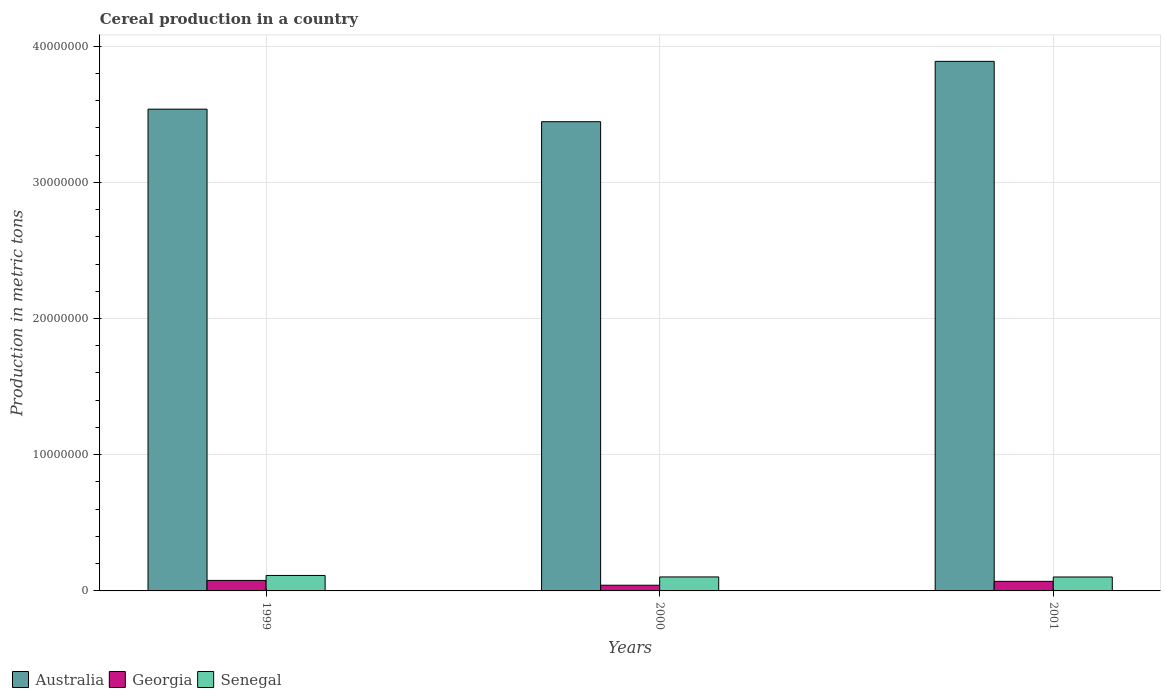How many bars are there on the 1st tick from the left?
Offer a very short reply. 3. What is the total cereal production in Senegal in 2000?
Offer a terse response. 1.03e+06. Across all years, what is the maximum total cereal production in Australia?
Keep it short and to the point. 3.89e+07. Across all years, what is the minimum total cereal production in Senegal?
Give a very brief answer. 1.02e+06. In which year was the total cereal production in Georgia maximum?
Your response must be concise. 1999. What is the total total cereal production in Georgia in the graph?
Provide a short and direct response. 1.89e+06. What is the difference between the total cereal production in Georgia in 1999 and that in 2000?
Make the answer very short. 3.53e+05. What is the difference between the total cereal production in Australia in 2000 and the total cereal production in Georgia in 2001?
Your response must be concise. 3.37e+07. What is the average total cereal production in Georgia per year?
Your answer should be very brief. 6.31e+05. In the year 1999, what is the difference between the total cereal production in Georgia and total cereal production in Australia?
Make the answer very short. -3.46e+07. In how many years, is the total cereal production in Georgia greater than 38000000 metric tons?
Keep it short and to the point. 0. What is the ratio of the total cereal production in Senegal in 1999 to that in 2000?
Your response must be concise. 1.1. Is the total cereal production in Senegal in 1999 less than that in 2001?
Offer a terse response. No. Is the difference between the total cereal production in Georgia in 1999 and 2001 greater than the difference between the total cereal production in Australia in 1999 and 2001?
Offer a terse response. Yes. What is the difference between the highest and the second highest total cereal production in Georgia?
Provide a short and direct response. 6.74e+04. What is the difference between the highest and the lowest total cereal production in Georgia?
Keep it short and to the point. 3.53e+05. What does the 1st bar from the left in 1999 represents?
Your answer should be very brief. Australia. What does the 2nd bar from the right in 2001 represents?
Provide a succinct answer. Georgia. Is it the case that in every year, the sum of the total cereal production in Georgia and total cereal production in Senegal is greater than the total cereal production in Australia?
Your response must be concise. No. How many bars are there?
Your answer should be very brief. 9. Are all the bars in the graph horizontal?
Your answer should be compact. No. How many years are there in the graph?
Your answer should be compact. 3. Are the values on the major ticks of Y-axis written in scientific E-notation?
Provide a succinct answer. No. Does the graph contain grids?
Offer a terse response. Yes. What is the title of the graph?
Give a very brief answer. Cereal production in a country. What is the label or title of the X-axis?
Offer a very short reply. Years. What is the label or title of the Y-axis?
Offer a very short reply. Production in metric tons. What is the Production in metric tons of Australia in 1999?
Ensure brevity in your answer.  3.54e+07. What is the Production in metric tons in Georgia in 1999?
Provide a short and direct response. 7.71e+05. What is the Production in metric tons of Senegal in 1999?
Make the answer very short. 1.13e+06. What is the Production in metric tons of Australia in 2000?
Provide a succinct answer. 3.44e+07. What is the Production in metric tons of Georgia in 2000?
Make the answer very short. 4.18e+05. What is the Production in metric tons of Senegal in 2000?
Offer a terse response. 1.03e+06. What is the Production in metric tons in Australia in 2001?
Keep it short and to the point. 3.89e+07. What is the Production in metric tons of Georgia in 2001?
Your response must be concise. 7.04e+05. What is the Production in metric tons of Senegal in 2001?
Provide a succinct answer. 1.02e+06. Across all years, what is the maximum Production in metric tons of Australia?
Offer a terse response. 3.89e+07. Across all years, what is the maximum Production in metric tons of Georgia?
Your response must be concise. 7.71e+05. Across all years, what is the maximum Production in metric tons of Senegal?
Give a very brief answer. 1.13e+06. Across all years, what is the minimum Production in metric tons in Australia?
Your answer should be very brief. 3.44e+07. Across all years, what is the minimum Production in metric tons in Georgia?
Keep it short and to the point. 4.18e+05. Across all years, what is the minimum Production in metric tons in Senegal?
Your answer should be compact. 1.02e+06. What is the total Production in metric tons in Australia in the graph?
Provide a short and direct response. 1.09e+08. What is the total Production in metric tons of Georgia in the graph?
Keep it short and to the point. 1.89e+06. What is the total Production in metric tons of Senegal in the graph?
Offer a terse response. 3.18e+06. What is the difference between the Production in metric tons of Australia in 1999 and that in 2000?
Your response must be concise. 9.22e+05. What is the difference between the Production in metric tons of Georgia in 1999 and that in 2000?
Ensure brevity in your answer.  3.53e+05. What is the difference between the Production in metric tons in Senegal in 1999 and that in 2000?
Make the answer very short. 1.07e+05. What is the difference between the Production in metric tons of Australia in 1999 and that in 2001?
Ensure brevity in your answer.  -3.51e+06. What is the difference between the Production in metric tons of Georgia in 1999 and that in 2001?
Give a very brief answer. 6.74e+04. What is the difference between the Production in metric tons in Senegal in 1999 and that in 2001?
Your response must be concise. 1.11e+05. What is the difference between the Production in metric tons in Australia in 2000 and that in 2001?
Your answer should be compact. -4.43e+06. What is the difference between the Production in metric tons of Georgia in 2000 and that in 2001?
Your response must be concise. -2.86e+05. What is the difference between the Production in metric tons in Senegal in 2000 and that in 2001?
Keep it short and to the point. 3565. What is the difference between the Production in metric tons of Australia in 1999 and the Production in metric tons of Georgia in 2000?
Offer a terse response. 3.50e+07. What is the difference between the Production in metric tons of Australia in 1999 and the Production in metric tons of Senegal in 2000?
Your response must be concise. 3.43e+07. What is the difference between the Production in metric tons in Georgia in 1999 and the Production in metric tons in Senegal in 2000?
Keep it short and to the point. -2.56e+05. What is the difference between the Production in metric tons in Australia in 1999 and the Production in metric tons in Georgia in 2001?
Your answer should be compact. 3.47e+07. What is the difference between the Production in metric tons in Australia in 1999 and the Production in metric tons in Senegal in 2001?
Provide a short and direct response. 3.43e+07. What is the difference between the Production in metric tons of Georgia in 1999 and the Production in metric tons of Senegal in 2001?
Your response must be concise. -2.52e+05. What is the difference between the Production in metric tons in Australia in 2000 and the Production in metric tons in Georgia in 2001?
Your response must be concise. 3.37e+07. What is the difference between the Production in metric tons of Australia in 2000 and the Production in metric tons of Senegal in 2001?
Your answer should be compact. 3.34e+07. What is the difference between the Production in metric tons of Georgia in 2000 and the Production in metric tons of Senegal in 2001?
Your answer should be compact. -6.06e+05. What is the average Production in metric tons of Australia per year?
Provide a short and direct response. 3.62e+07. What is the average Production in metric tons in Georgia per year?
Give a very brief answer. 6.31e+05. What is the average Production in metric tons in Senegal per year?
Offer a very short reply. 1.06e+06. In the year 1999, what is the difference between the Production in metric tons of Australia and Production in metric tons of Georgia?
Provide a succinct answer. 3.46e+07. In the year 1999, what is the difference between the Production in metric tons of Australia and Production in metric tons of Senegal?
Provide a succinct answer. 3.42e+07. In the year 1999, what is the difference between the Production in metric tons in Georgia and Production in metric tons in Senegal?
Make the answer very short. -3.63e+05. In the year 2000, what is the difference between the Production in metric tons in Australia and Production in metric tons in Georgia?
Make the answer very short. 3.40e+07. In the year 2000, what is the difference between the Production in metric tons of Australia and Production in metric tons of Senegal?
Keep it short and to the point. 3.34e+07. In the year 2000, what is the difference between the Production in metric tons in Georgia and Production in metric tons in Senegal?
Give a very brief answer. -6.09e+05. In the year 2001, what is the difference between the Production in metric tons in Australia and Production in metric tons in Georgia?
Your answer should be very brief. 3.82e+07. In the year 2001, what is the difference between the Production in metric tons in Australia and Production in metric tons in Senegal?
Offer a terse response. 3.79e+07. In the year 2001, what is the difference between the Production in metric tons in Georgia and Production in metric tons in Senegal?
Your answer should be compact. -3.20e+05. What is the ratio of the Production in metric tons in Australia in 1999 to that in 2000?
Your response must be concise. 1.03. What is the ratio of the Production in metric tons of Georgia in 1999 to that in 2000?
Provide a short and direct response. 1.85. What is the ratio of the Production in metric tons of Senegal in 1999 to that in 2000?
Give a very brief answer. 1.1. What is the ratio of the Production in metric tons of Australia in 1999 to that in 2001?
Ensure brevity in your answer.  0.91. What is the ratio of the Production in metric tons in Georgia in 1999 to that in 2001?
Provide a succinct answer. 1.1. What is the ratio of the Production in metric tons in Senegal in 1999 to that in 2001?
Offer a terse response. 1.11. What is the ratio of the Production in metric tons in Australia in 2000 to that in 2001?
Offer a terse response. 0.89. What is the ratio of the Production in metric tons of Georgia in 2000 to that in 2001?
Keep it short and to the point. 0.59. What is the difference between the highest and the second highest Production in metric tons in Australia?
Give a very brief answer. 3.51e+06. What is the difference between the highest and the second highest Production in metric tons of Georgia?
Your answer should be very brief. 6.74e+04. What is the difference between the highest and the second highest Production in metric tons in Senegal?
Ensure brevity in your answer.  1.07e+05. What is the difference between the highest and the lowest Production in metric tons of Australia?
Keep it short and to the point. 4.43e+06. What is the difference between the highest and the lowest Production in metric tons of Georgia?
Your answer should be very brief. 3.53e+05. What is the difference between the highest and the lowest Production in metric tons of Senegal?
Your answer should be compact. 1.11e+05. 